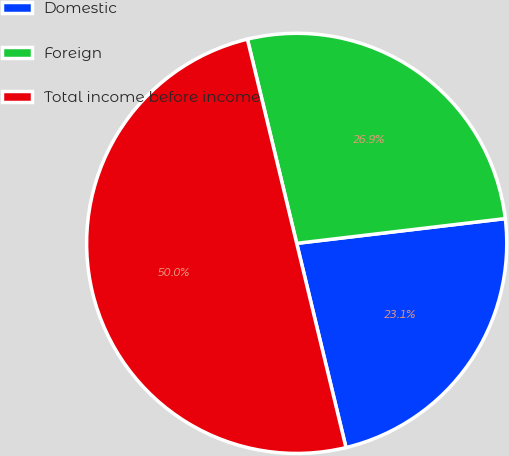<chart> <loc_0><loc_0><loc_500><loc_500><pie_chart><fcel>Domestic<fcel>Foreign<fcel>Total income before income<nl><fcel>23.11%<fcel>26.89%<fcel>50.0%<nl></chart> 